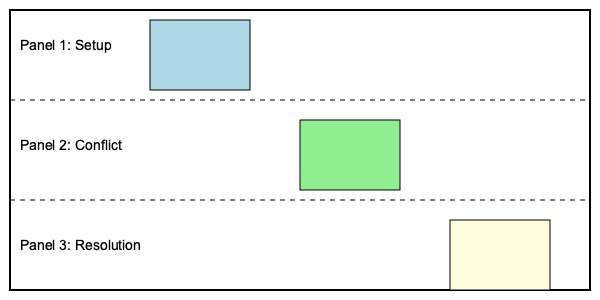In creating a visual storyboard sequence for a pivotal plot moment in a children's book, which essential element should be prominently featured in Panel 2 (the middle panel) to effectively drive the narrative forward? To create an effective visual storyboard sequence for a pivotal plot moment in a children's book, we need to consider the three-act structure commonly used in storytelling:

1. Panel 1 (Setup): This panel introduces the characters and sets the scene. It should establish the status quo or the initial situation.

2. Panel 2 (Conflict): This is the crucial middle panel where the main conflict or challenge should be prominently featured. It's the turning point that disrupts the status quo and drives the story forward.

3. Panel 3 (Resolution): This panel shows the outcome or resolution of the conflict, often depicting how the characters have changed or grown.

In Panel 2, the conflict or challenge should be the focal point because:

a) It creates tension and engages the young readers.
b) It presents the main obstacle the characters must overcome.
c) It sets up the need for a resolution, making the story more compelling.
d) It often reveals character traits through their reactions to the conflict.
e) It's the catalyst for character growth and development.

For a children's book author, making this conflict visually clear and emotionally resonant is crucial. The conflict should be age-appropriate and relatable to the target audience while still being impactful enough to drive the story forward.

Therefore, the essential element that should be prominently featured in Panel 2 is the main conflict or challenge of the pivotal plot moment.
Answer: The main conflict or challenge 